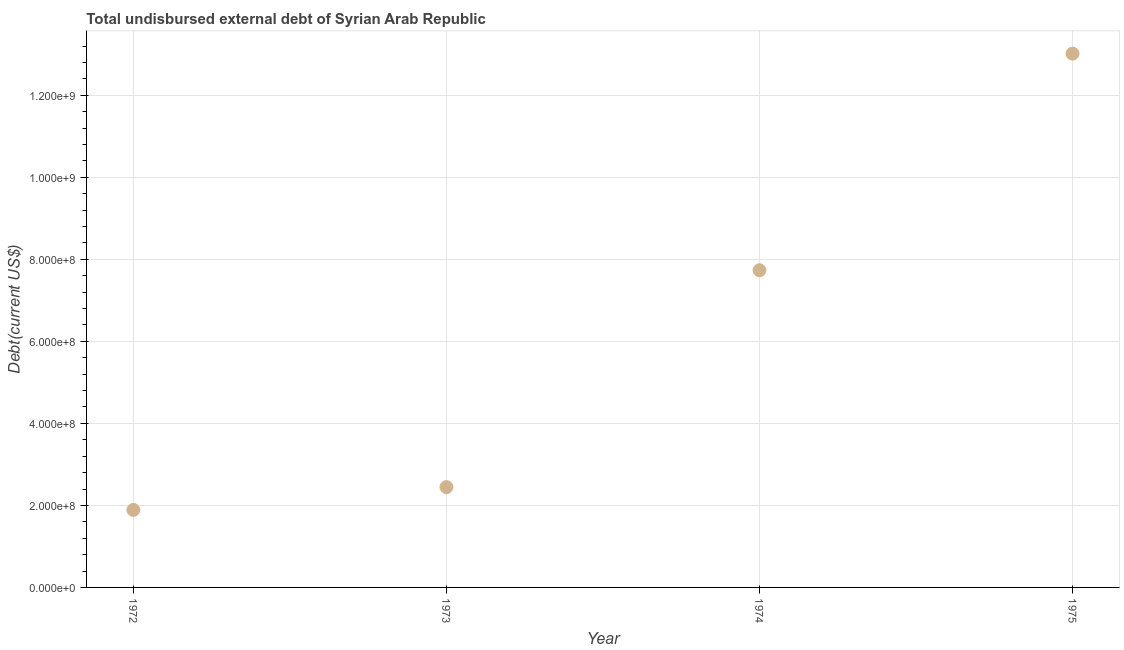What is the total debt in 1973?
Ensure brevity in your answer.  2.45e+08. Across all years, what is the maximum total debt?
Your response must be concise. 1.30e+09. Across all years, what is the minimum total debt?
Offer a terse response. 1.89e+08. In which year was the total debt maximum?
Give a very brief answer. 1975. What is the sum of the total debt?
Your response must be concise. 2.51e+09. What is the difference between the total debt in 1972 and 1973?
Your answer should be very brief. -5.56e+07. What is the average total debt per year?
Make the answer very short. 6.27e+08. What is the median total debt?
Provide a short and direct response. 5.09e+08. Do a majority of the years between 1974 and 1972 (inclusive) have total debt greater than 640000000 US$?
Ensure brevity in your answer.  No. What is the ratio of the total debt in 1972 to that in 1973?
Offer a terse response. 0.77. Is the difference between the total debt in 1974 and 1975 greater than the difference between any two years?
Your answer should be compact. No. What is the difference between the highest and the second highest total debt?
Keep it short and to the point. 5.28e+08. What is the difference between the highest and the lowest total debt?
Offer a terse response. 1.11e+09. In how many years, is the total debt greater than the average total debt taken over all years?
Provide a short and direct response. 2. How many dotlines are there?
Offer a terse response. 1. How many years are there in the graph?
Offer a terse response. 4. Are the values on the major ticks of Y-axis written in scientific E-notation?
Your answer should be compact. Yes. Does the graph contain any zero values?
Provide a short and direct response. No. What is the title of the graph?
Make the answer very short. Total undisbursed external debt of Syrian Arab Republic. What is the label or title of the Y-axis?
Your response must be concise. Debt(current US$). What is the Debt(current US$) in 1972?
Offer a very short reply. 1.89e+08. What is the Debt(current US$) in 1973?
Keep it short and to the point. 2.45e+08. What is the Debt(current US$) in 1974?
Your answer should be very brief. 7.74e+08. What is the Debt(current US$) in 1975?
Your answer should be compact. 1.30e+09. What is the difference between the Debt(current US$) in 1972 and 1973?
Your response must be concise. -5.56e+07. What is the difference between the Debt(current US$) in 1972 and 1974?
Your answer should be compact. -5.85e+08. What is the difference between the Debt(current US$) in 1972 and 1975?
Your answer should be very brief. -1.11e+09. What is the difference between the Debt(current US$) in 1973 and 1974?
Ensure brevity in your answer.  -5.29e+08. What is the difference between the Debt(current US$) in 1973 and 1975?
Make the answer very short. -1.06e+09. What is the difference between the Debt(current US$) in 1974 and 1975?
Keep it short and to the point. -5.28e+08. What is the ratio of the Debt(current US$) in 1972 to that in 1973?
Ensure brevity in your answer.  0.77. What is the ratio of the Debt(current US$) in 1972 to that in 1974?
Offer a terse response. 0.24. What is the ratio of the Debt(current US$) in 1972 to that in 1975?
Make the answer very short. 0.14. What is the ratio of the Debt(current US$) in 1973 to that in 1974?
Offer a very short reply. 0.32. What is the ratio of the Debt(current US$) in 1973 to that in 1975?
Provide a succinct answer. 0.19. What is the ratio of the Debt(current US$) in 1974 to that in 1975?
Offer a very short reply. 0.59. 